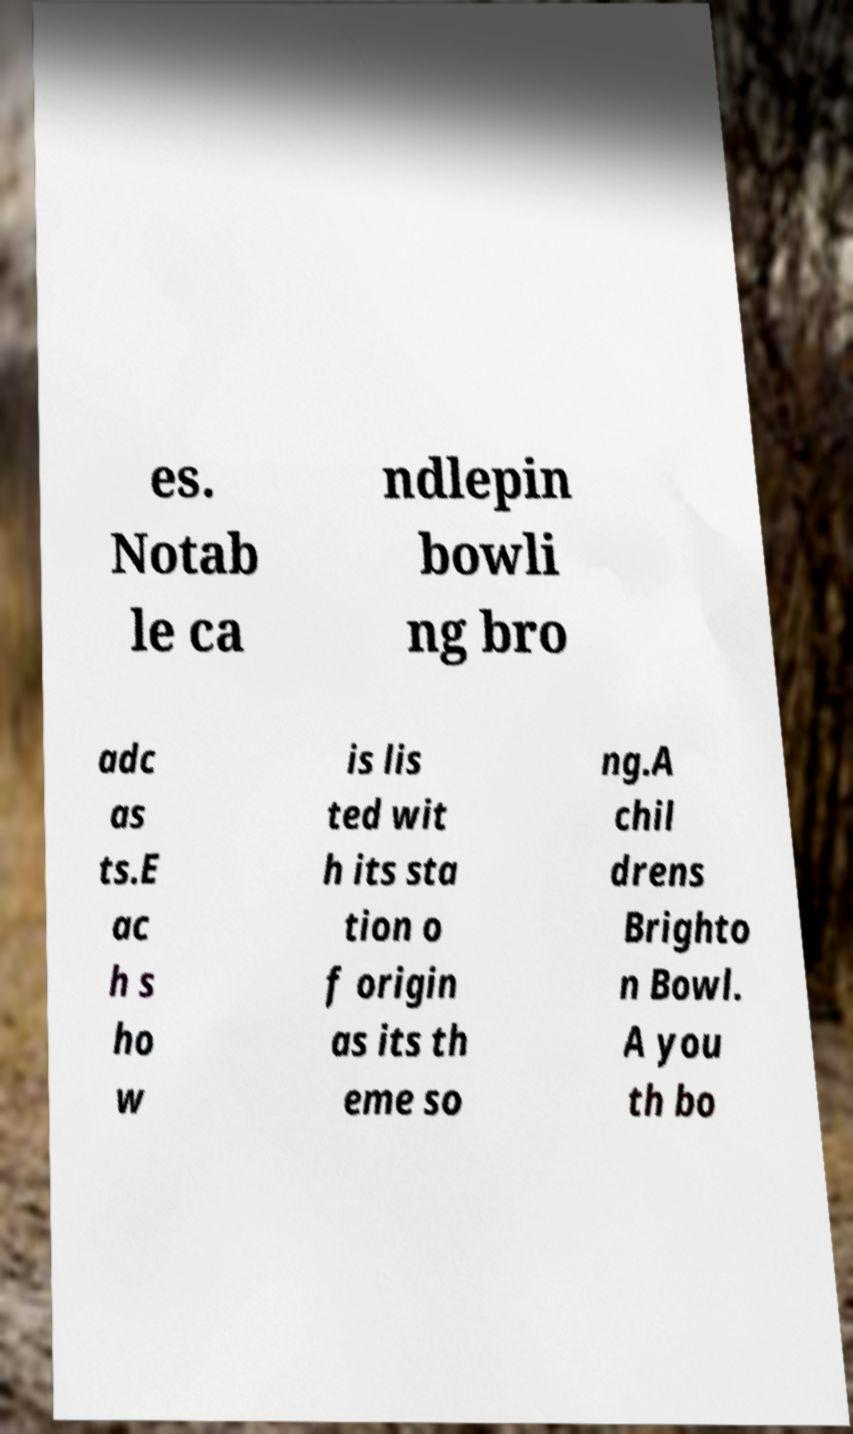I need the written content from this picture converted into text. Can you do that? es. Notab le ca ndlepin bowli ng bro adc as ts.E ac h s ho w is lis ted wit h its sta tion o f origin as its th eme so ng.A chil drens Brighto n Bowl. A you th bo 